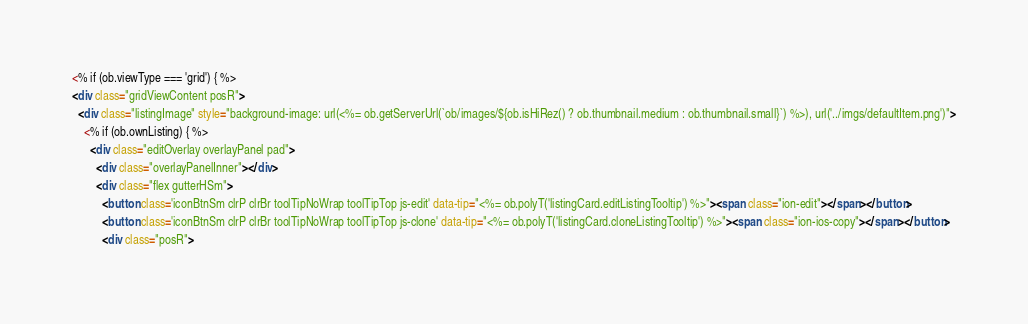<code> <loc_0><loc_0><loc_500><loc_500><_HTML_><% if (ob.viewType === 'grid') { %>
<div class="gridViewContent posR">
  <div class="listingImage" style="background-image: url(<%= ob.getServerUrl(`ob/images/${ob.isHiRez() ? ob.thumbnail.medium : ob.thumbnail.small}`) %>), url('../imgs/defaultItem.png')">
    <% if (ob.ownListing) { %>
      <div class="editOverlay overlayPanel pad">
        <div class="overlayPanelInner"></div>
        <div class="flex gutterHSm">
          <button class='iconBtnSm clrP clrBr toolTipNoWrap toolTipTop js-edit' data-tip="<%= ob.polyT('listingCard.editListingTooltip') %>"><span class="ion-edit"></span></button>
          <button class='iconBtnSm clrP clrBr toolTipNoWrap toolTipTop js-clone' data-tip="<%= ob.polyT('listingCard.cloneListingTooltip') %>"><span class="ion-ios-copy"></span></button>
          <div class="posR"></code> 